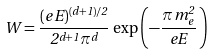Convert formula to latex. <formula><loc_0><loc_0><loc_500><loc_500>W = \frac { ( e \, E ) ^ { ( d + 1 ) / 2 } } { 2 ^ { d + 1 } \pi ^ { d } } \, \exp \left ( - \frac { \pi \, m ^ { 2 } _ { e } } { e E } \, \right )</formula> 